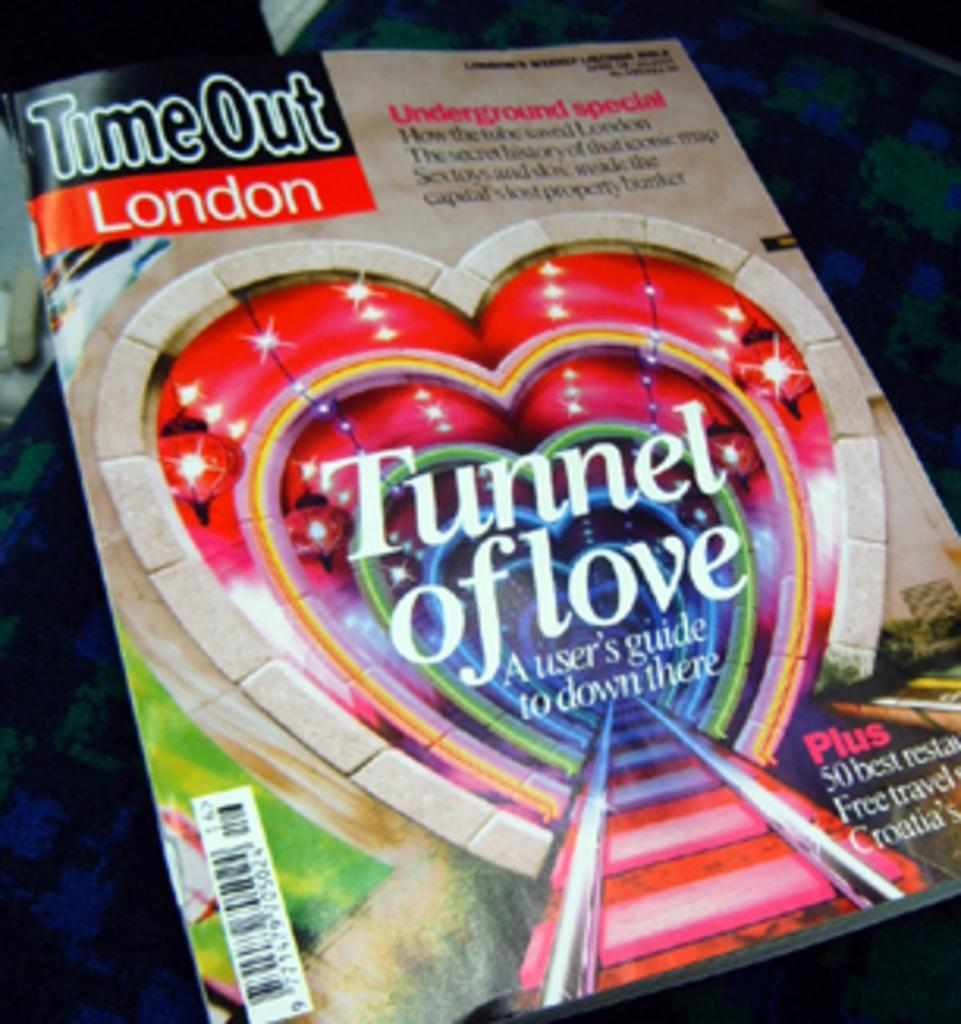<image>
Summarize the visual content of the image. A copy of Time Out London has a feature about the Tunnel of Love. 